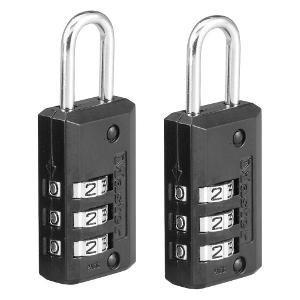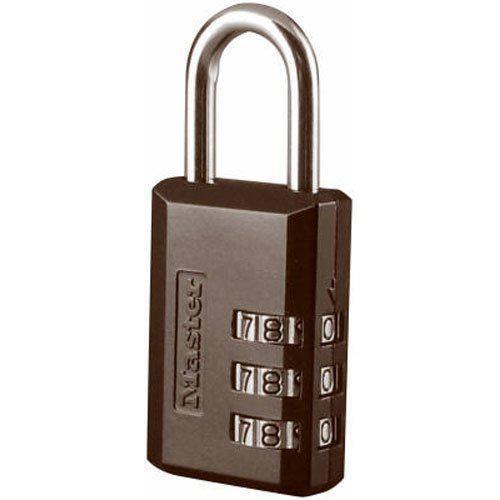The first image is the image on the left, the second image is the image on the right. Given the left and right images, does the statement "An image features exactly one combination lock, which is black." hold true? Answer yes or no. No. The first image is the image on the left, the second image is the image on the right. Examine the images to the left and right. Is the description "All locks have a loop on the top and exactly three rows of number belts on the front of the lock." accurate? Answer yes or no. Yes. 